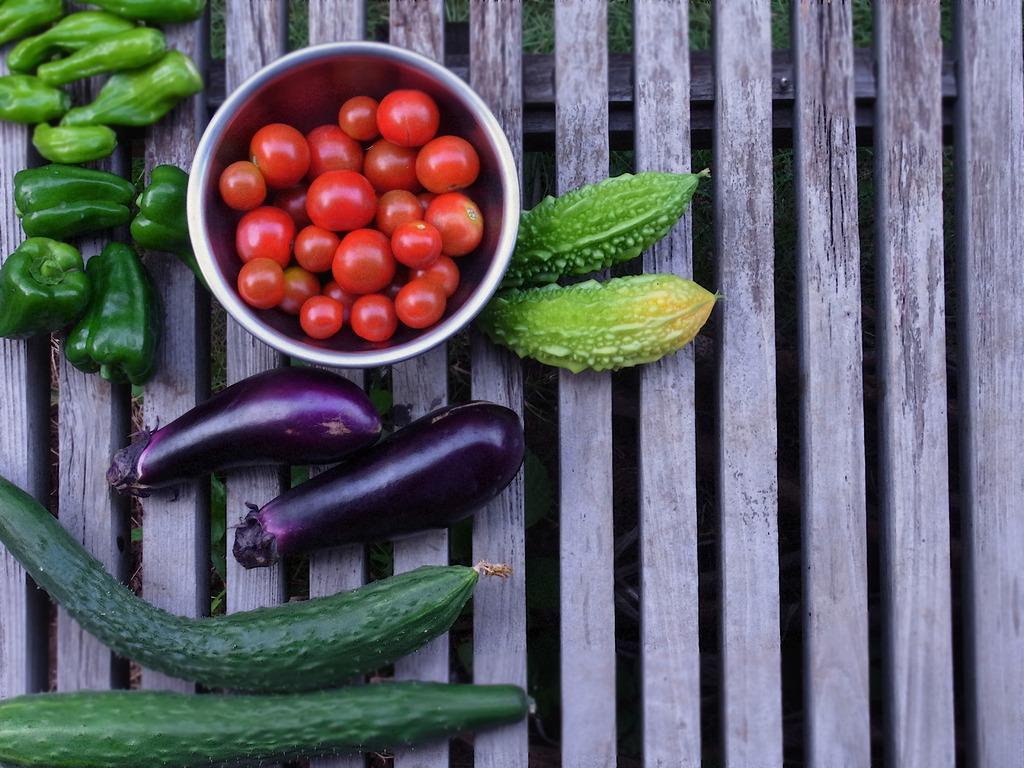In one or two sentences, can you explain what this image depicts? In this image we can see some vegetables such as egg plant, cucumber, bitter guard, capsicum and a bowl of tomatoes which are placed on the wooden surface. We can also see some grass. 